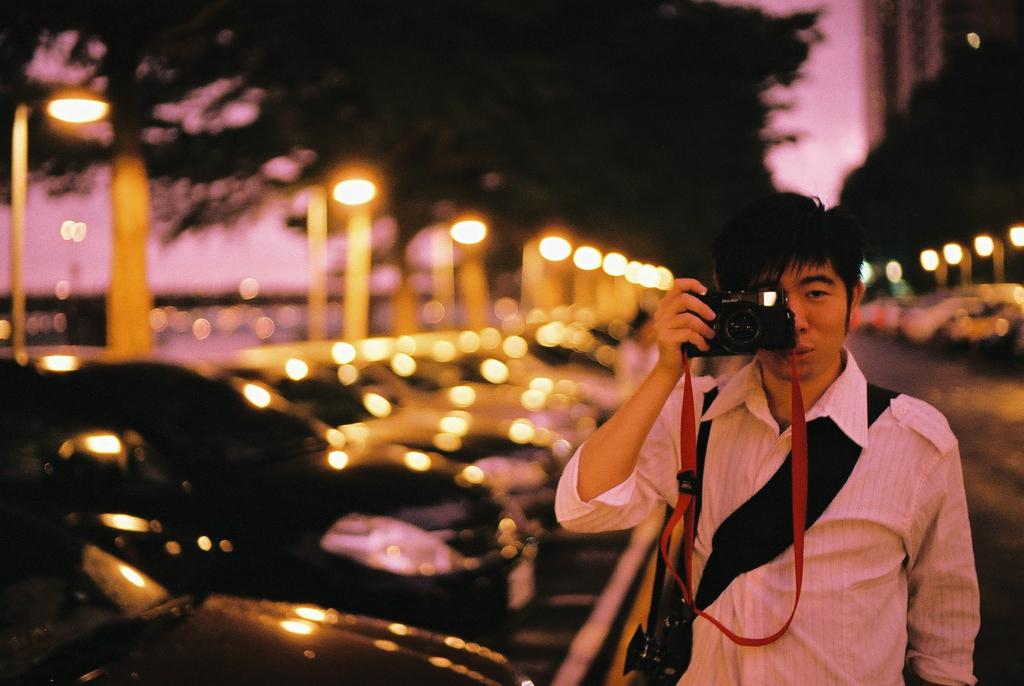What is the man in the image doing? The man is taking a picture, as he is holding a camera in one hand. What is the man holding in his hand? The man is holding a camera in one hand. What can be seen beside the man in the image? There are cars parked beside the man. What is visible in the background of the image? There are trees and light visible in the background of the image. How would you describe the quality of the image? The image appears to be blurry. What book is the man reading in the image? There is no book present in the image, and the man is taking a picture, not reading. 